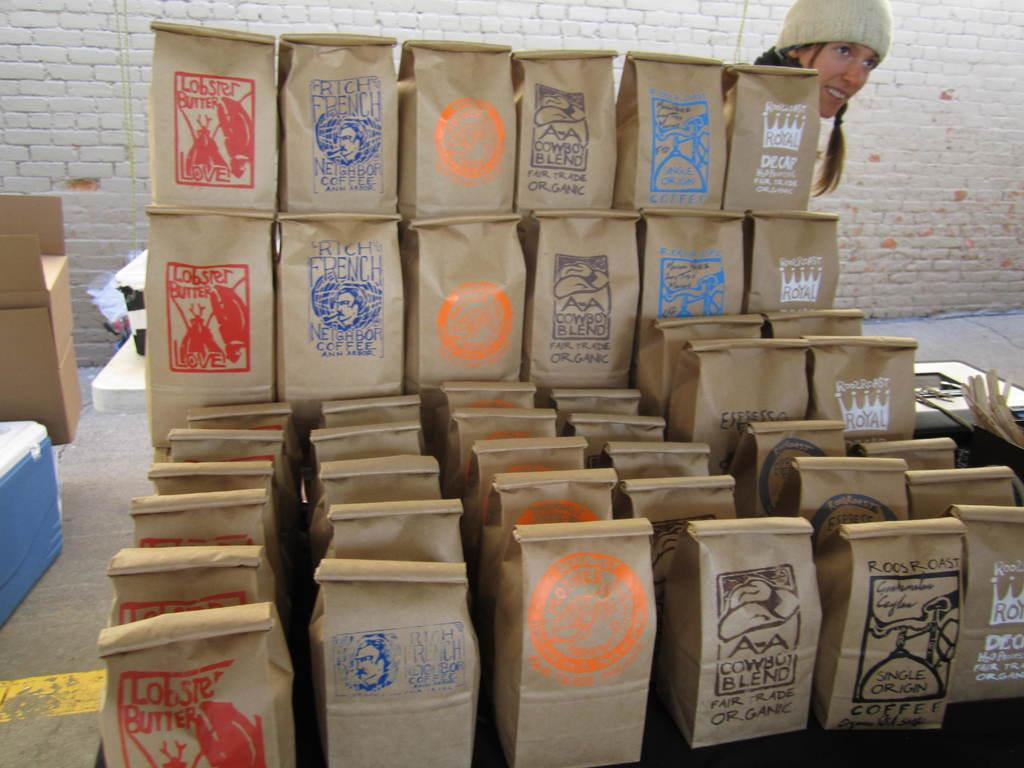What type of bags are visible in the image? There are paper bags in the image. Can you describe the woman's attire in the image? The woman is wearing a cap in the image. What other objects can be seen in the image? There is a box, a wall, and a floor in the image. What is the color of the line visible in the image? There is a yellow line in the image. What advertisement is being displayed on the wall in the image? There is no advertisement present on the wall in the image; it only shows a wall and other objects. How many toes can be seen on the woman's foot in the image? There is no visible foot or toes of the woman in the image. 